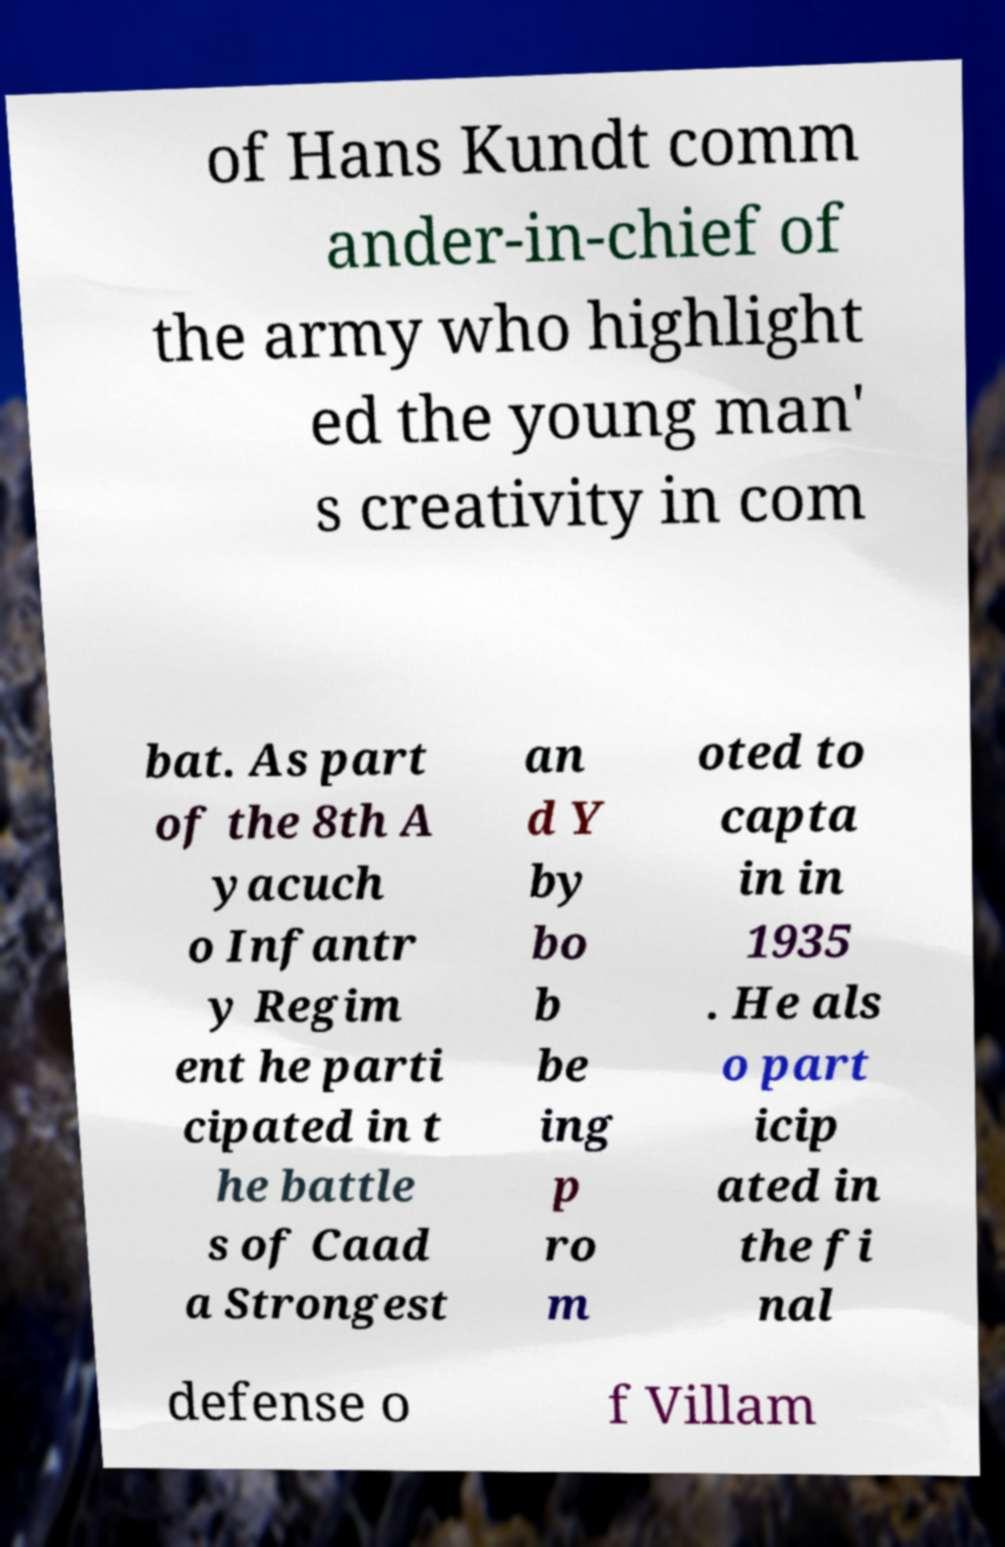Can you accurately transcribe the text from the provided image for me? of Hans Kundt comm ander-in-chief of the army who highlight ed the young man' s creativity in com bat. As part of the 8th A yacuch o Infantr y Regim ent he parti cipated in t he battle s of Caad a Strongest an d Y by bo b be ing p ro m oted to capta in in 1935 . He als o part icip ated in the fi nal defense o f Villam 